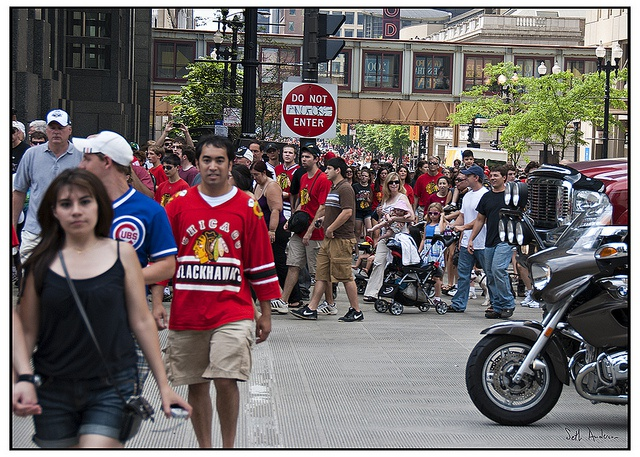Describe the objects in this image and their specific colors. I can see people in white, black, gray, and darkgray tones, people in white, black, gray, darkgray, and lightgray tones, people in white, brown, maroon, gray, and darkgray tones, motorcycle in white, black, gray, darkgray, and lightgray tones, and car in white, black, gray, and darkgray tones in this image. 